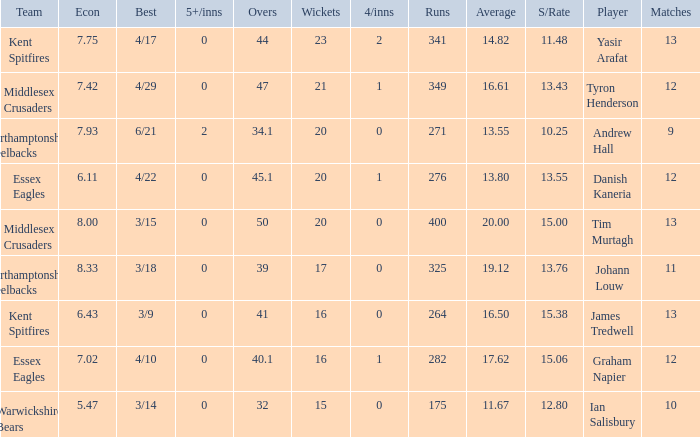Name the matches for wickets 17 11.0. 